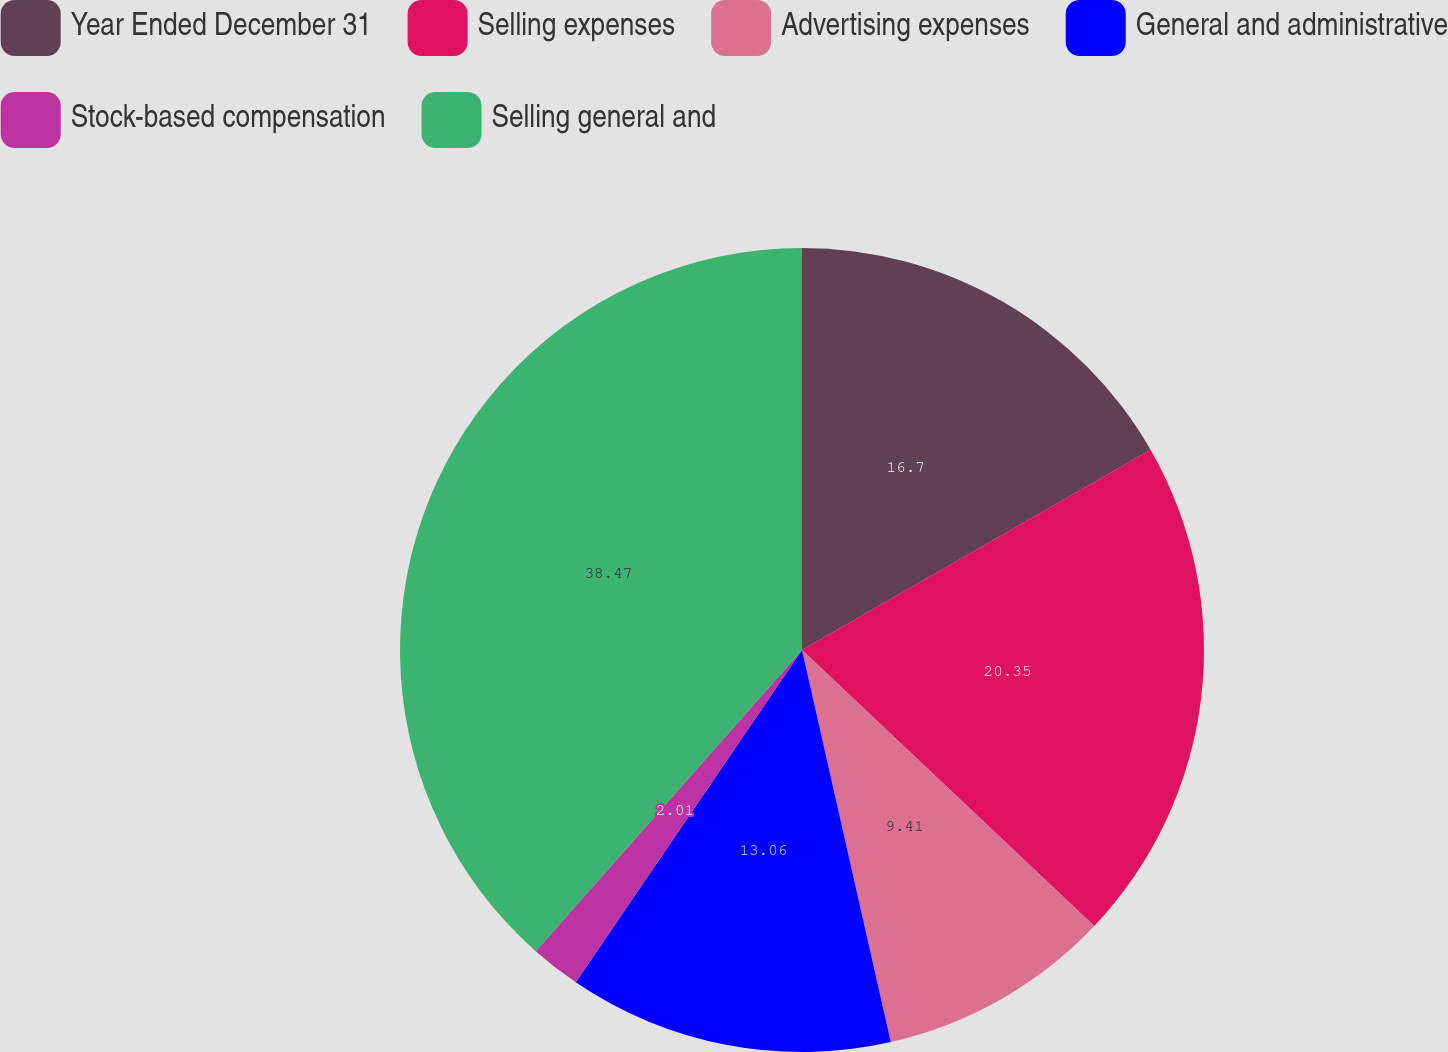<chart> <loc_0><loc_0><loc_500><loc_500><pie_chart><fcel>Year Ended December 31<fcel>Selling expenses<fcel>Advertising expenses<fcel>General and administrative<fcel>Stock-based compensation<fcel>Selling general and<nl><fcel>16.7%<fcel>20.35%<fcel>9.41%<fcel>13.06%<fcel>2.01%<fcel>38.48%<nl></chart> 